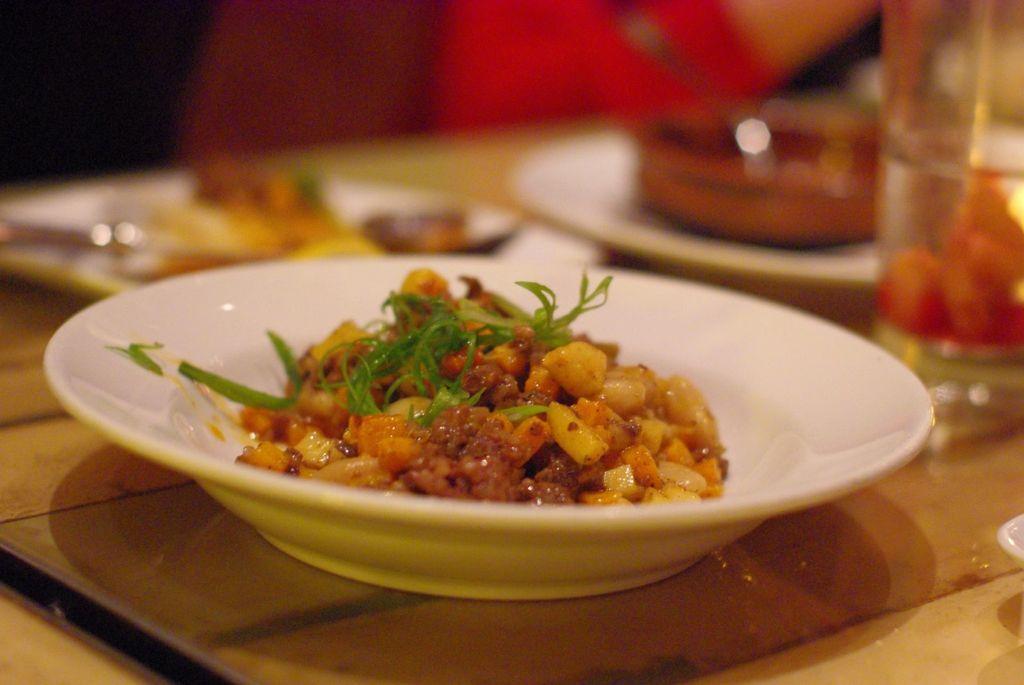Please provide a concise description of this image. In the image there is corn dish along with some leaves on a plate over a dining table, beside it there are two plates with food and water jug, in the back it seems to be a person. 